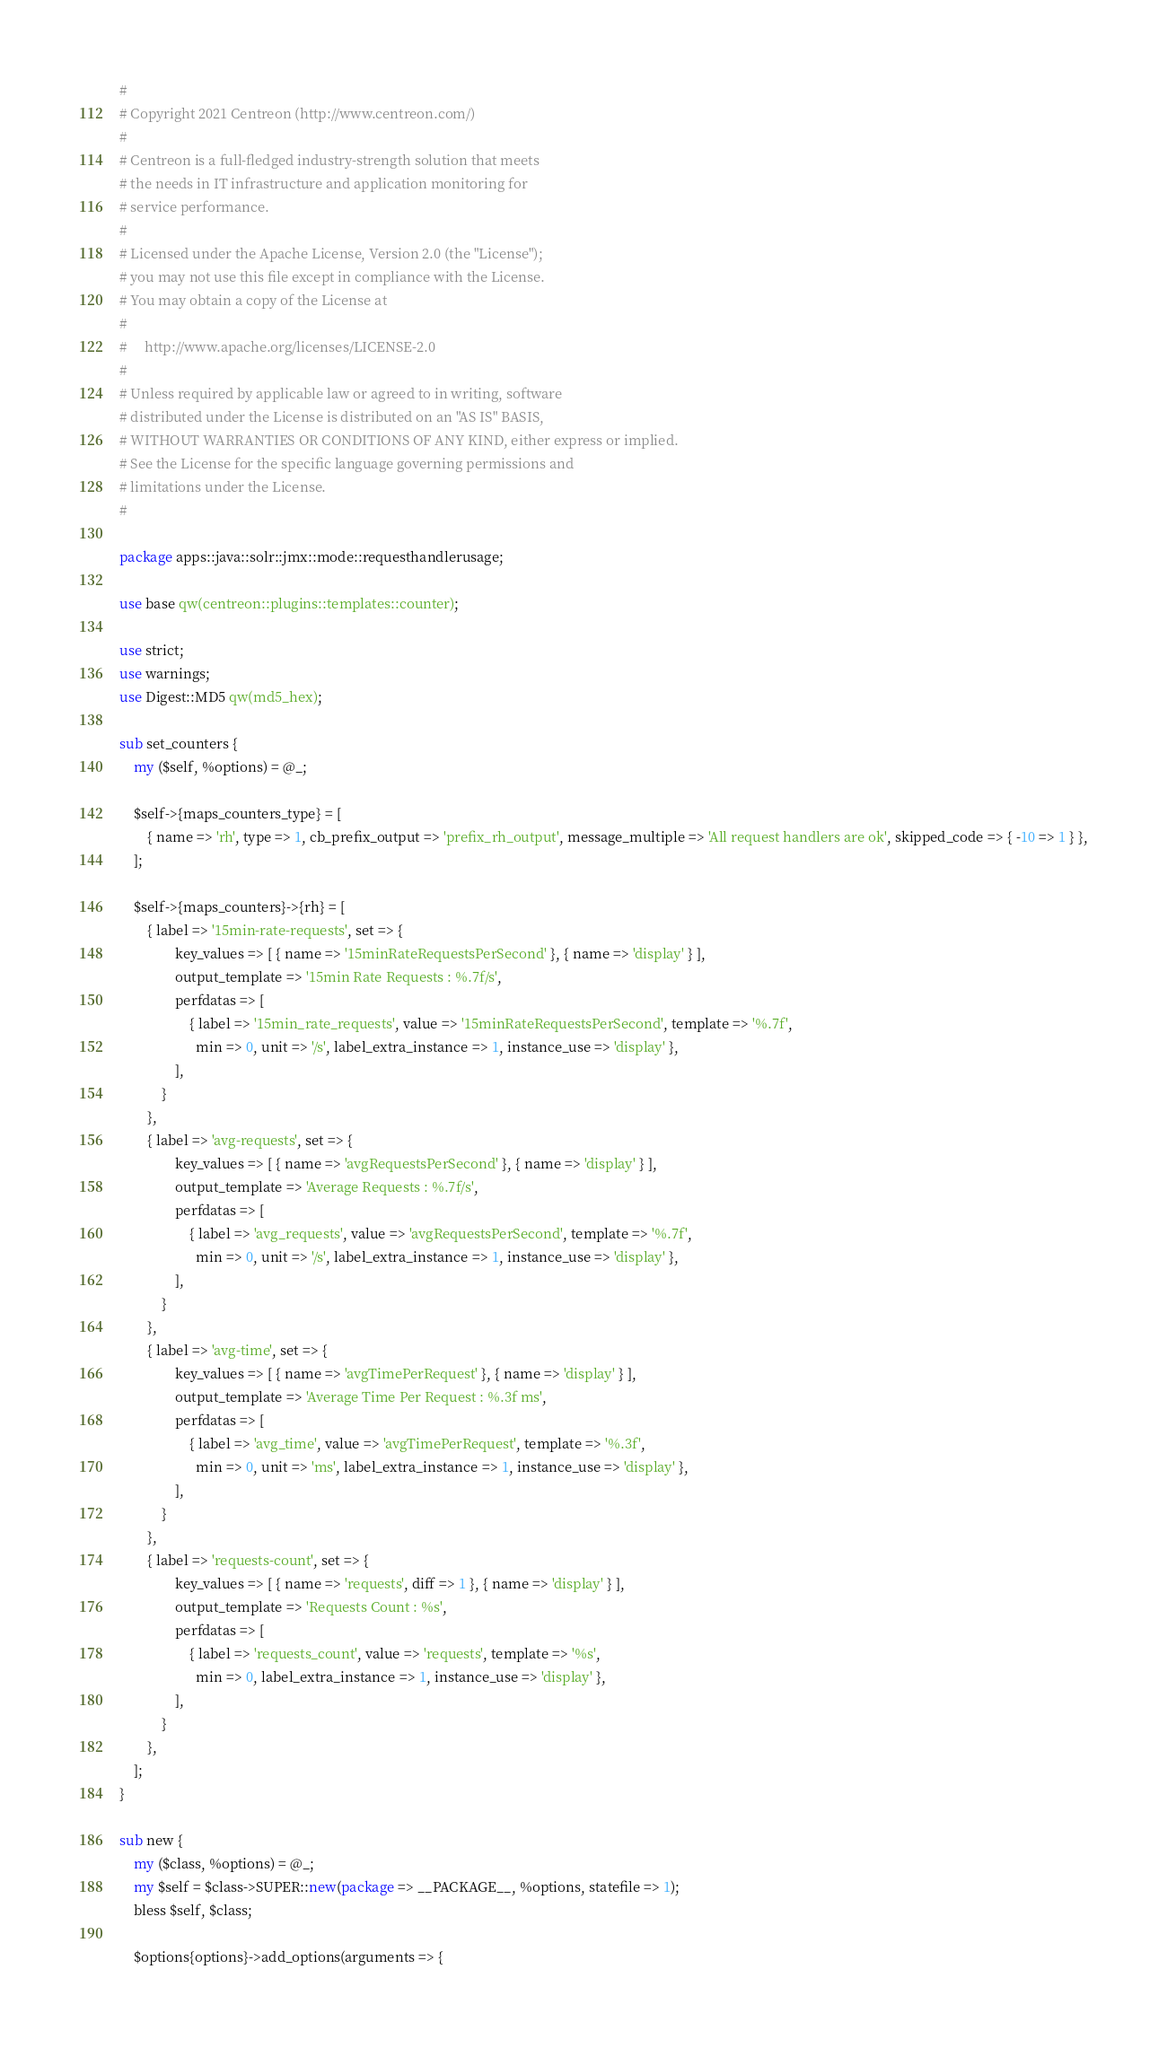Convert code to text. <code><loc_0><loc_0><loc_500><loc_500><_Perl_>#
# Copyright 2021 Centreon (http://www.centreon.com/)
#
# Centreon is a full-fledged industry-strength solution that meets
# the needs in IT infrastructure and application monitoring for
# service performance.
#
# Licensed under the Apache License, Version 2.0 (the "License");
# you may not use this file except in compliance with the License.
# You may obtain a copy of the License at
#
#     http://www.apache.org/licenses/LICENSE-2.0
#
# Unless required by applicable law or agreed to in writing, software
# distributed under the License is distributed on an "AS IS" BASIS,
# WITHOUT WARRANTIES OR CONDITIONS OF ANY KIND, either express or implied.
# See the License for the specific language governing permissions and
# limitations under the License.
#

package apps::java::solr::jmx::mode::requesthandlerusage;

use base qw(centreon::plugins::templates::counter);

use strict;
use warnings;
use Digest::MD5 qw(md5_hex);

sub set_counters {
    my ($self, %options) = @_;
    
    $self->{maps_counters_type} = [
        { name => 'rh', type => 1, cb_prefix_output => 'prefix_rh_output', message_multiple => 'All request handlers are ok', skipped_code => { -10 => 1 } },
    ];

    $self->{maps_counters}->{rh} = [
        { label => '15min-rate-requests', set => {
                key_values => [ { name => '15minRateRequestsPerSecond' }, { name => 'display' } ],
                output_template => '15min Rate Requests : %.7f/s',
                perfdatas => [
                    { label => '15min_rate_requests', value => '15minRateRequestsPerSecond', template => '%.7f', 
                      min => 0, unit => '/s', label_extra_instance => 1, instance_use => 'display' },
                ],
            }
        },
        { label => 'avg-requests', set => {
                key_values => [ { name => 'avgRequestsPerSecond' }, { name => 'display' } ],
                output_template => 'Average Requests : %.7f/s',
                perfdatas => [
                    { label => 'avg_requests', value => 'avgRequestsPerSecond', template => '%.7f',
                      min => 0, unit => '/s', label_extra_instance => 1, instance_use => 'display' },
                ],
            }
        },
        { label => 'avg-time', set => {
                key_values => [ { name => 'avgTimePerRequest' }, { name => 'display' } ],
                output_template => 'Average Time Per Request : %.3f ms',
                perfdatas => [
                    { label => 'avg_time', value => 'avgTimePerRequest', template => '%.3f', 
                      min => 0, unit => 'ms', label_extra_instance => 1, instance_use => 'display' },
                ],
            }
        },
        { label => 'requests-count', set => {
                key_values => [ { name => 'requests', diff => 1 }, { name => 'display' } ],
                output_template => 'Requests Count : %s',
                perfdatas => [
                    { label => 'requests_count', value => 'requests', template => '%s', 
                      min => 0, label_extra_instance => 1, instance_use => 'display' },
                ],
            }
        },
    ];
}

sub new {
    my ($class, %options) = @_;
    my $self = $class->SUPER::new(package => __PACKAGE__, %options, statefile => 1);
    bless $self, $class;

    $options{options}->add_options(arguments => { </code> 